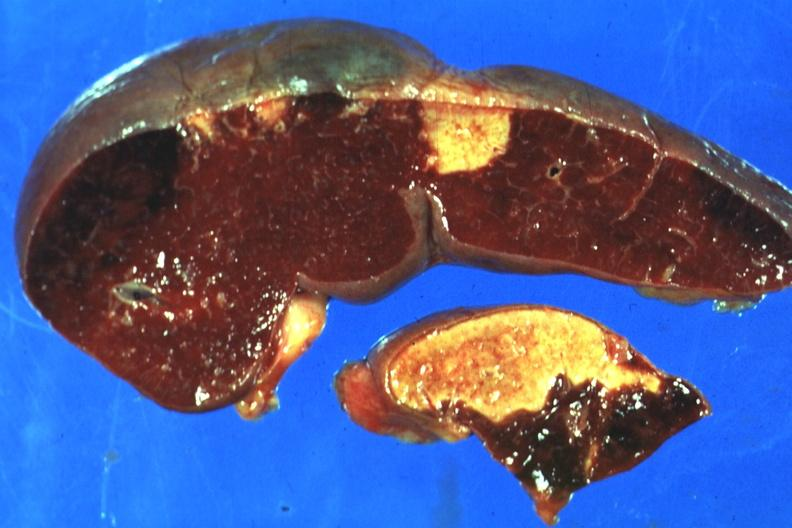what shown which are several days of age from nonbacterial endocarditis?
Answer the question using a single word or phrase. Excellent side with four infarcts 